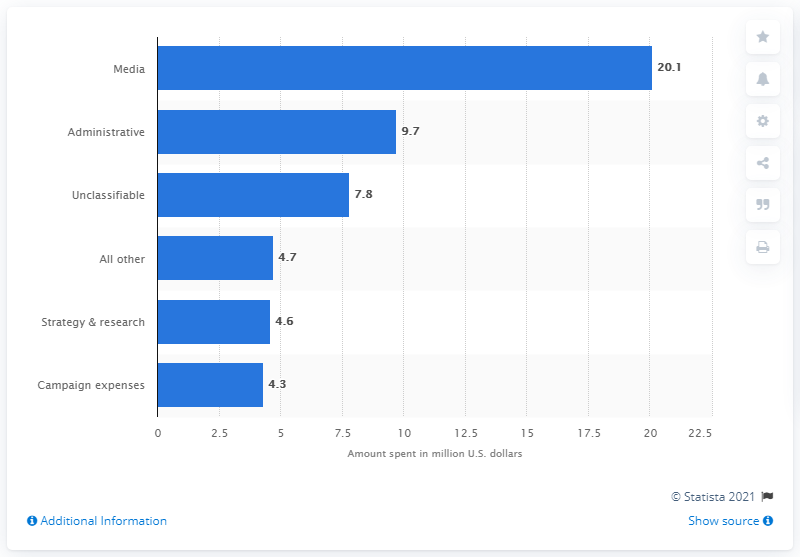Indicate a few pertinent items in this graphic. As of August 2016, Donald Trump's campaign had spent $20.1 million on media. 